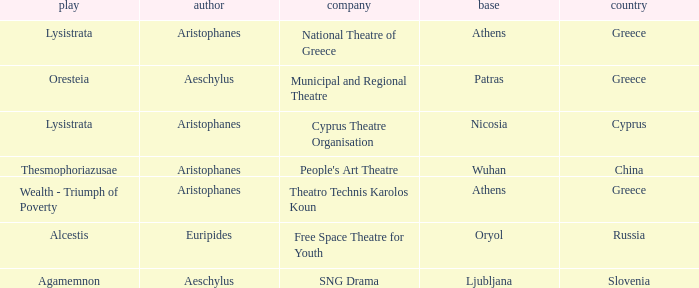What is the company when the base is ljubljana? SNG Drama. 